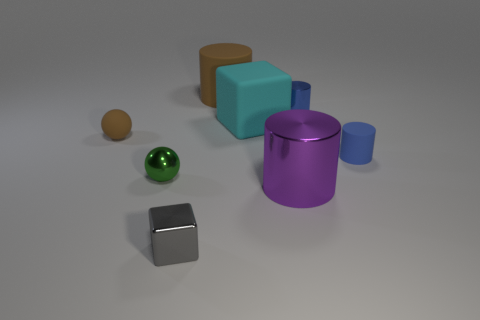Is there a big block of the same color as the large shiny cylinder?
Offer a very short reply. No. There is a small rubber object that is in front of the matte sphere; what number of metal cylinders are in front of it?
Your answer should be compact. 1. Are there more rubber spheres than big brown shiny things?
Give a very brief answer. Yes. Is the green thing made of the same material as the purple cylinder?
Offer a very short reply. Yes. Is the number of tiny brown things behind the small cube the same as the number of large brown things?
Give a very brief answer. Yes. How many cyan objects have the same material as the brown ball?
Offer a very short reply. 1. Is the number of brown spheres less than the number of tiny purple cylinders?
Your answer should be very brief. No. Do the tiny ball behind the tiny green metal sphere and the big rubber cylinder have the same color?
Make the answer very short. Yes. There is a brown object on the left side of the large cylinder that is behind the large purple object; what number of small blue cylinders are in front of it?
Keep it short and to the point. 1. There is a large brown cylinder; how many cyan rubber objects are behind it?
Your answer should be very brief. 0. 